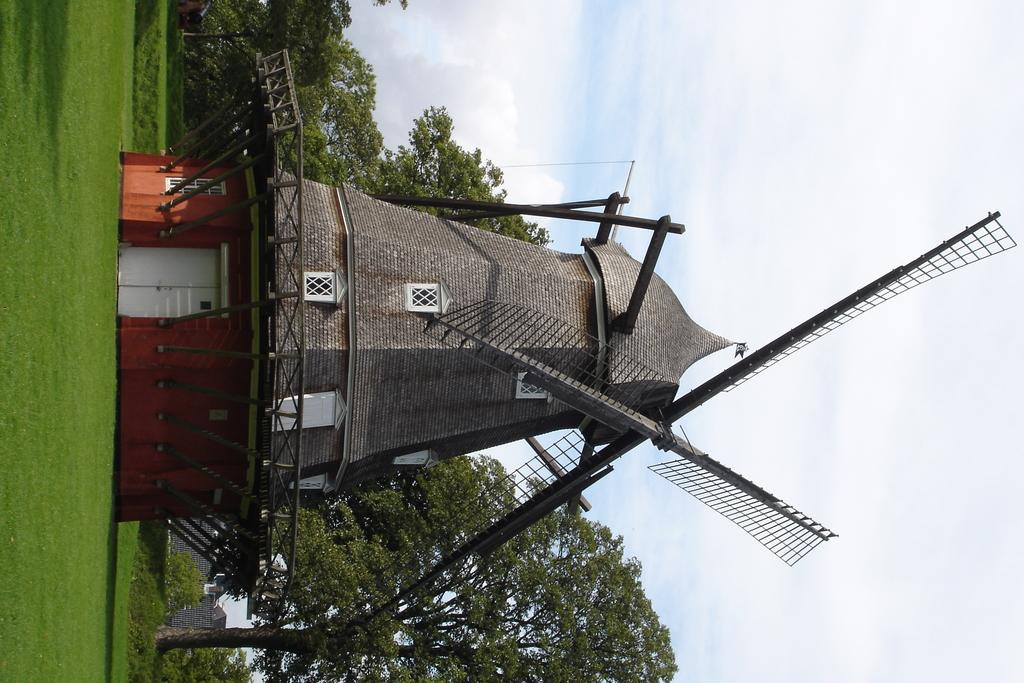What is the main subject in the picture? There is a windmill in the picture. What can be seen in the background of the picture? There are trees, grass, and the sky visible in the background of the picture. How does the windmill make the area quieter in the image? The windmill does not make the area quieter in the image; it is a stationary object and does not have any sound-reducing properties. 